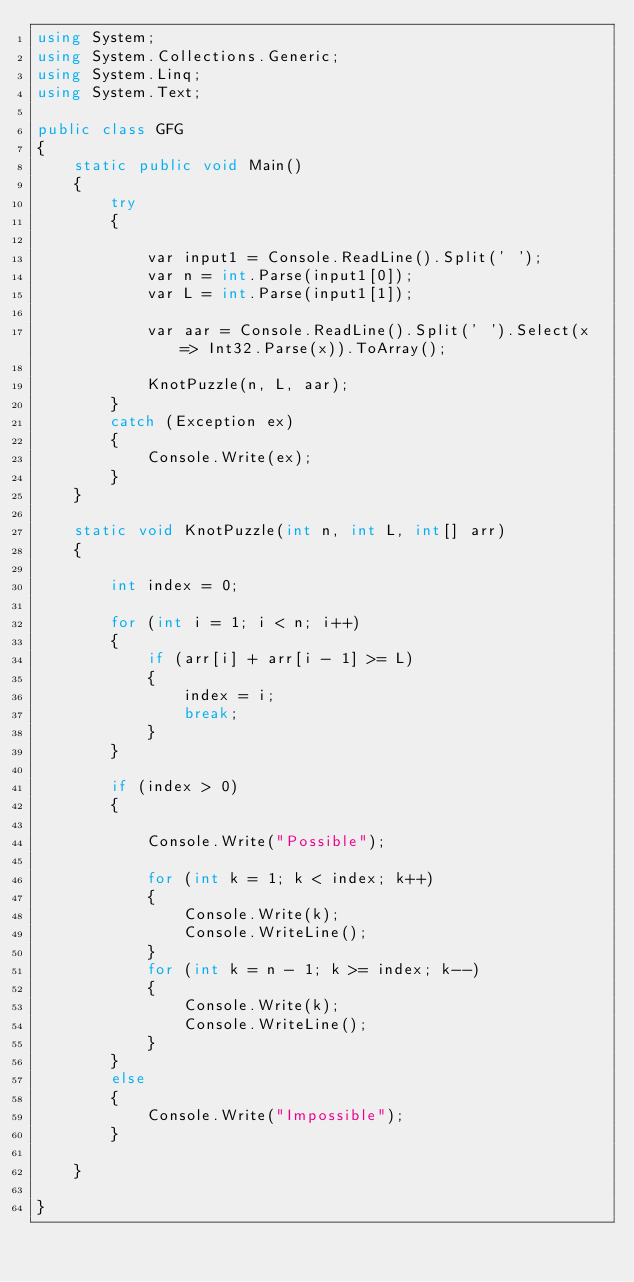Convert code to text. <code><loc_0><loc_0><loc_500><loc_500><_C#_>using System;
using System.Collections.Generic;
using System.Linq;
using System.Text;

public class GFG
{
    static public void Main()
    {
        try
        {

            var input1 = Console.ReadLine().Split(' ');
            var n = int.Parse(input1[0]);
            var L = int.Parse(input1[1]);

            var aar = Console.ReadLine().Split(' ').Select(x => Int32.Parse(x)).ToArray();

            KnotPuzzle(n, L, aar);
        }
        catch (Exception ex)
        {
            Console.Write(ex);
        }
    }

    static void KnotPuzzle(int n, int L, int[] arr)
    {

        int index = 0;

        for (int i = 1; i < n; i++)
        {
            if (arr[i] + arr[i - 1] >= L)
            {
                index = i;
                break;
            }
        }

        if (index > 0)
        {

            Console.Write("Possible");

            for (int k = 1; k < index; k++)
            {
                Console.Write(k);
                Console.WriteLine();
            }
            for (int k = n - 1; k >= index; k--)
            {
                Console.Write(k);
                Console.WriteLine();
            }
        }
        else
        {
            Console.Write("Impossible");
        }

    }

}</code> 